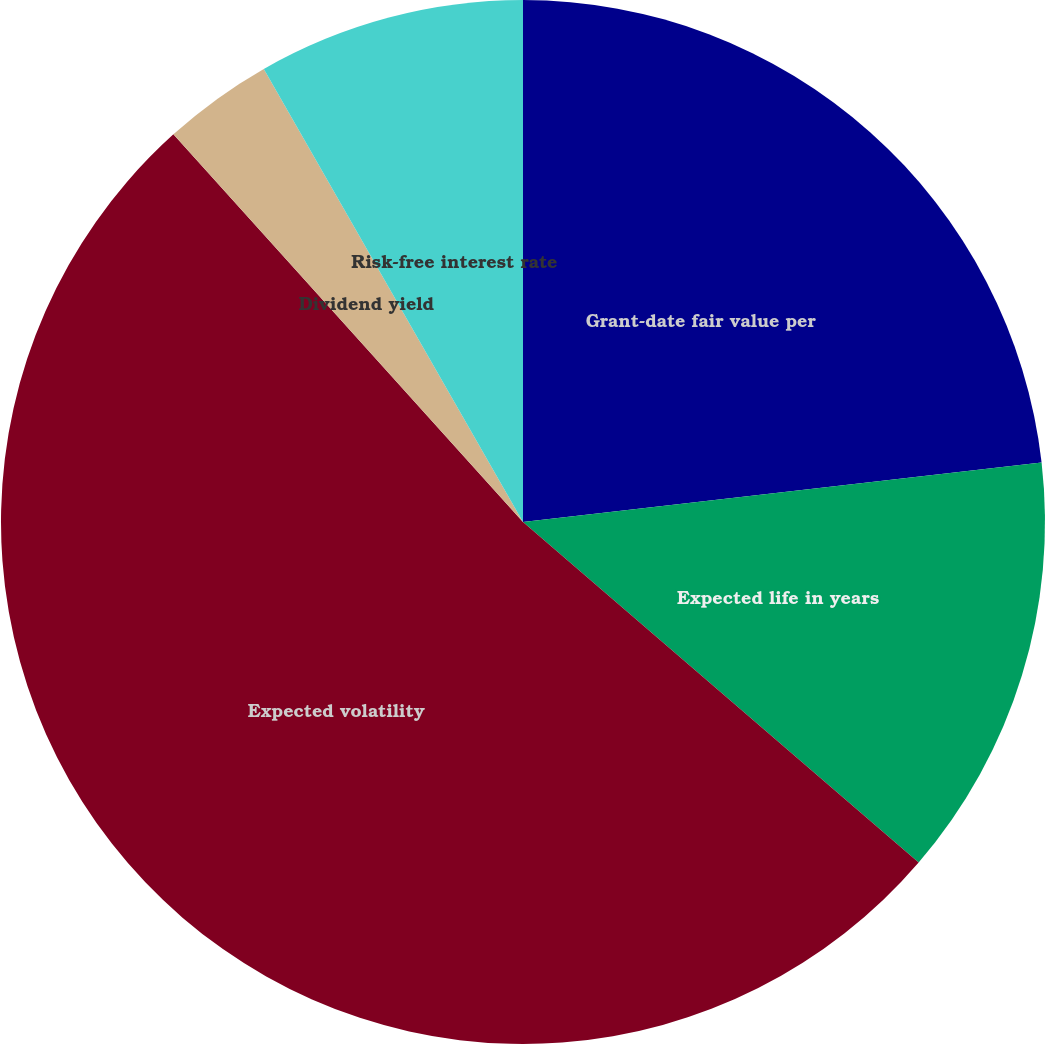<chart> <loc_0><loc_0><loc_500><loc_500><pie_chart><fcel>Grant-date fair value per<fcel>Expected life in years<fcel>Expected volatility<fcel>Dividend yield<fcel>Risk-free interest rate<nl><fcel>23.18%<fcel>13.13%<fcel>52.01%<fcel>3.41%<fcel>8.27%<nl></chart> 